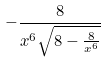Convert formula to latex. <formula><loc_0><loc_0><loc_500><loc_500>- \frac { 8 } { x ^ { 6 } \sqrt { 8 - \frac { 8 } { x ^ { 6 } } } }</formula> 